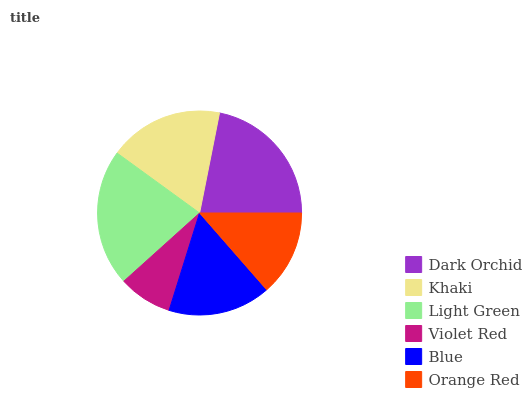Is Violet Red the minimum?
Answer yes or no. Yes. Is Dark Orchid the maximum?
Answer yes or no. Yes. Is Khaki the minimum?
Answer yes or no. No. Is Khaki the maximum?
Answer yes or no. No. Is Dark Orchid greater than Khaki?
Answer yes or no. Yes. Is Khaki less than Dark Orchid?
Answer yes or no. Yes. Is Khaki greater than Dark Orchid?
Answer yes or no. No. Is Dark Orchid less than Khaki?
Answer yes or no. No. Is Khaki the high median?
Answer yes or no. Yes. Is Blue the low median?
Answer yes or no. Yes. Is Dark Orchid the high median?
Answer yes or no. No. Is Light Green the low median?
Answer yes or no. No. 